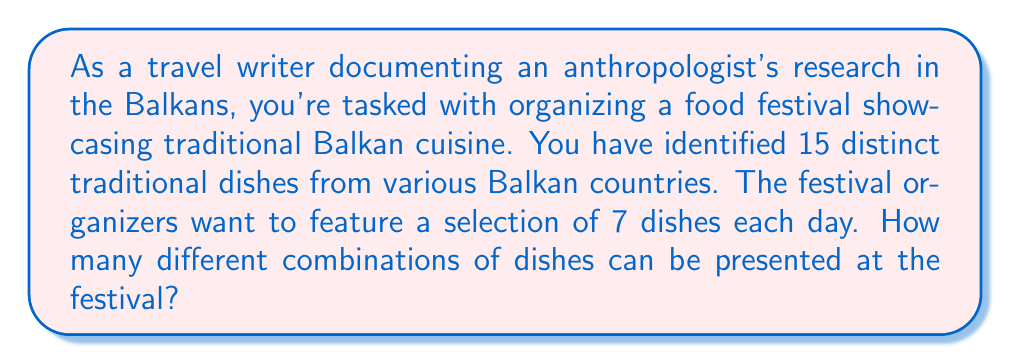Can you answer this question? To solve this problem, we need to use the combination formula. We are selecting 7 dishes out of 15, where the order doesn't matter (as we're just presenting a set of dishes each day, not arranging them in a specific order).

The formula for combinations is:

$$ C(n,r) = \frac{n!}{r!(n-r)!} $$

Where:
$n$ is the total number of items to choose from (in this case, 15 dishes)
$r$ is the number of items being chosen (in this case, 7 dishes)

Let's substitute these values:

$$ C(15,7) = \frac{15!}{7!(15-7)!} = \frac{15!}{7!(8)!} $$

Now, let's calculate this step-by-step:

1) $15! = 1,307,674,368,000$
2) $7! = 5,040$
3) $8! = 40,320$

Substituting these values:

$$ \frac{1,307,674,368,000}{5,040 \times 40,320} $$

4) $5,040 \times 40,320 = 203,212,800$

5) $\frac{1,307,674,368,000}{203,212,800} = 6,435$

Therefore, there are 6,435 different combinations of 7 dishes that can be selected from the 15 traditional Balkan dishes.
Answer: 6,435 combinations 